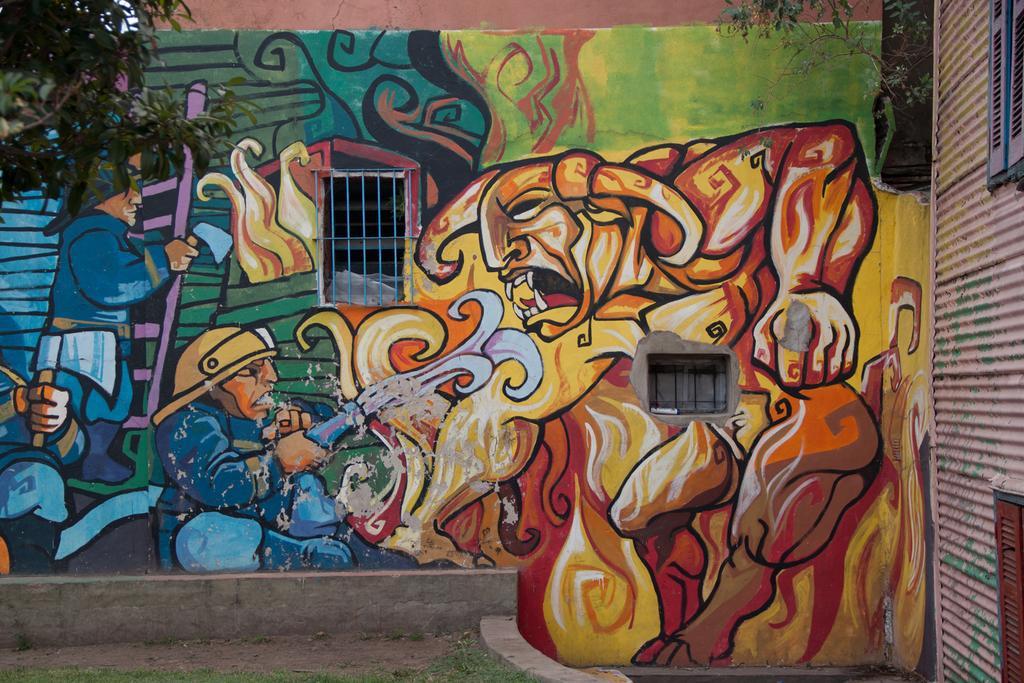How would you summarize this image in a sentence or two? In this image, we can see the wall with some art. We can also see some windows on the left. We can see some leaves in the top left corner. We can see the ground and some grass. We can also see a plant on one of the walls. 